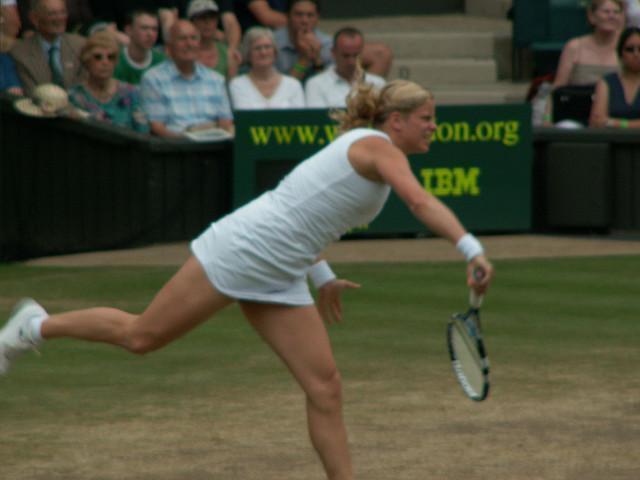How many people are there?
Give a very brief answer. 10. 